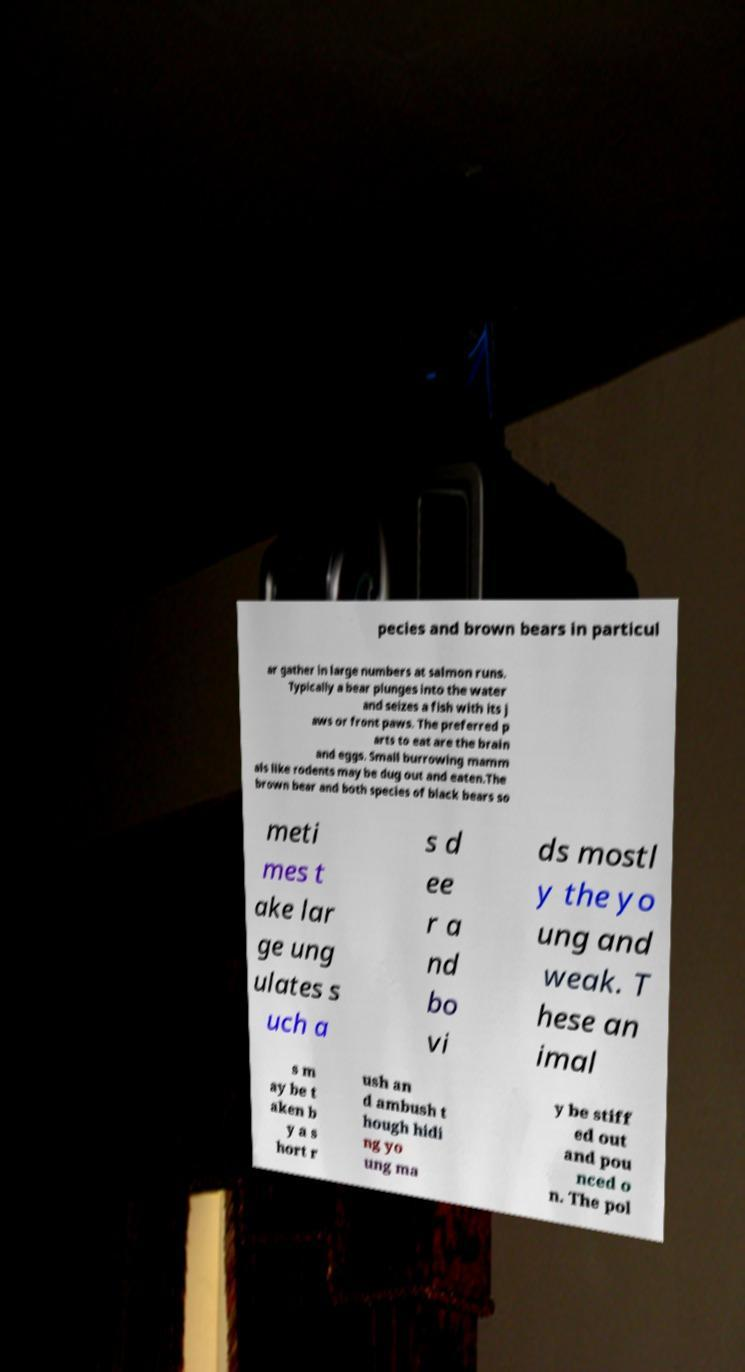I need the written content from this picture converted into text. Can you do that? pecies and brown bears in particul ar gather in large numbers at salmon runs. Typically a bear plunges into the water and seizes a fish with its j aws or front paws. The preferred p arts to eat are the brain and eggs. Small burrowing mamm als like rodents may be dug out and eaten.The brown bear and both species of black bears so meti mes t ake lar ge ung ulates s uch a s d ee r a nd bo vi ds mostl y the yo ung and weak. T hese an imal s m ay be t aken b y a s hort r ush an d ambush t hough hidi ng yo ung ma y be stiff ed out and pou nced o n. The pol 